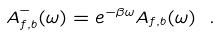Convert formula to latex. <formula><loc_0><loc_0><loc_500><loc_500>A ^ { - } _ { f , b } ( \omega ) = e ^ { - \beta \omega } A _ { f , b } ( \omega ) \ .</formula> 